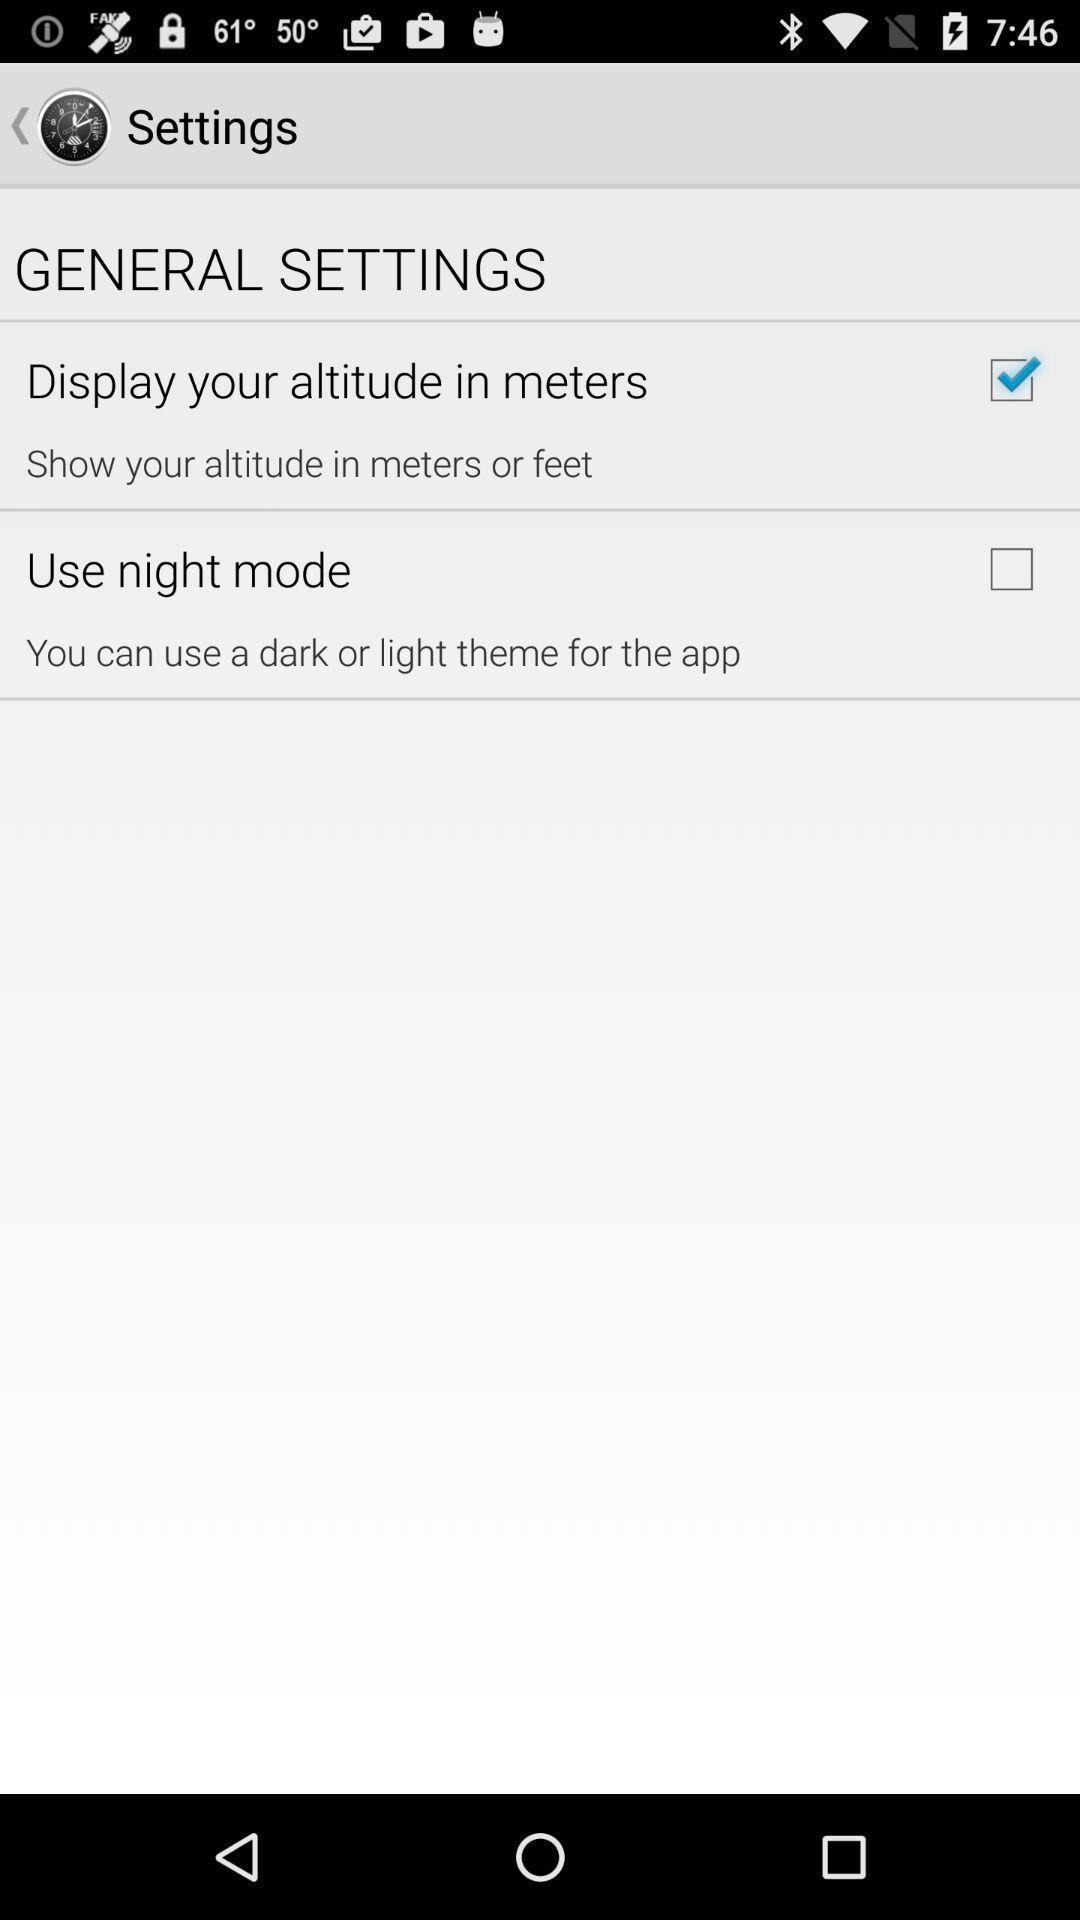Provide a detailed account of this screenshot. Screen shows few general settings. 